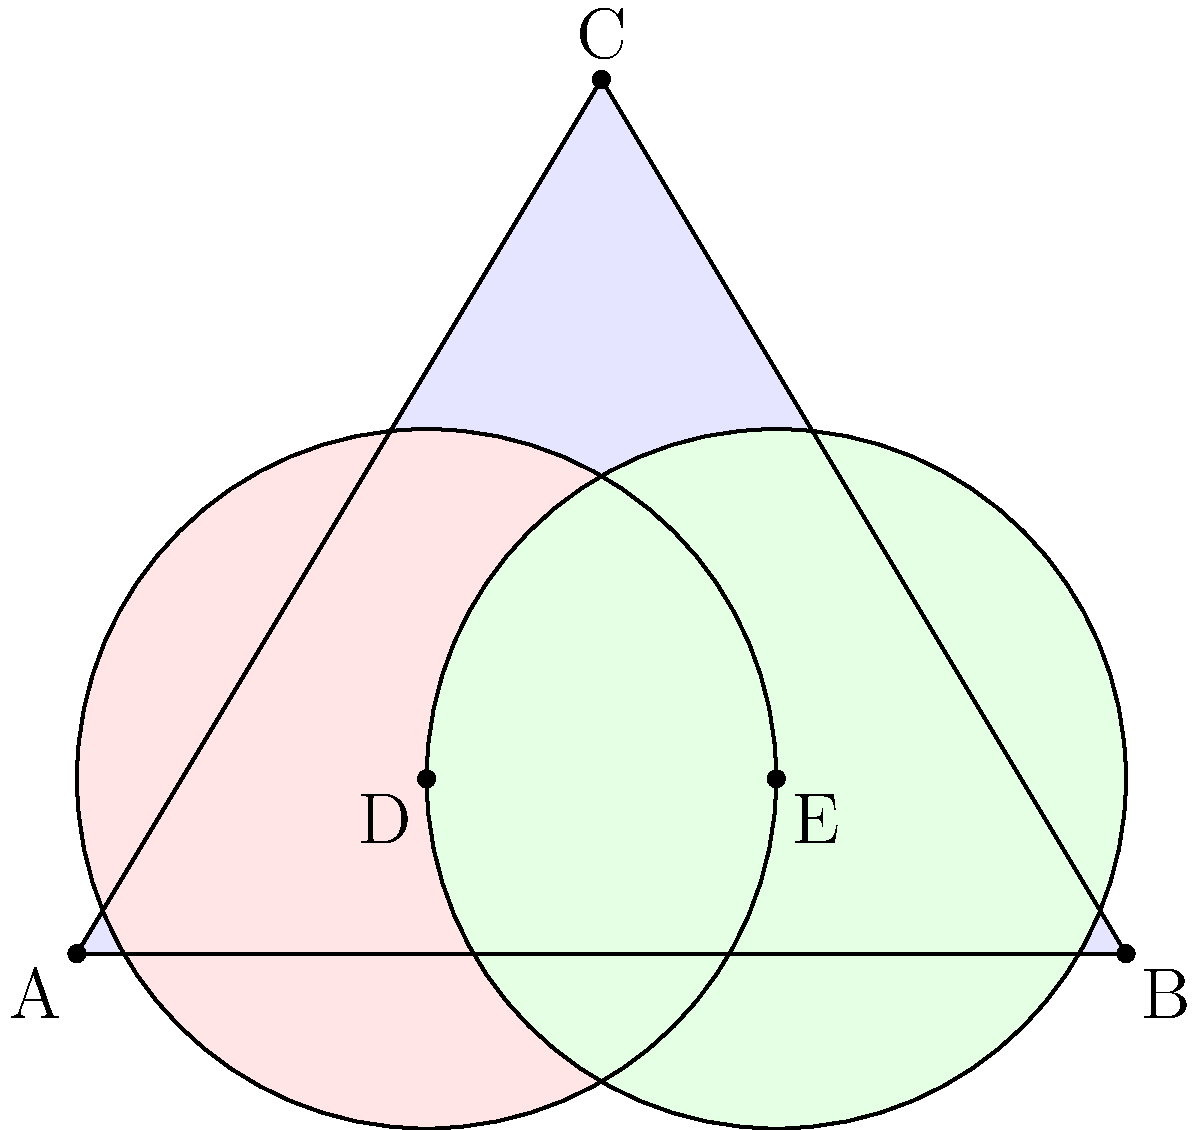In a city's crime mapping system, a triangular area ABC represents a neighborhood with coordinates A(0,0), B(6,0), and C(3,5). Two circular police precincts with radius 2 units are centered at D(2,1) and E(4,1). Calculate the area of the region that is covered by both precincts but lies outside the triangular neighborhood. How might this information be useful for optimizing police resource allocation? To solve this problem, we'll follow these steps:

1) First, we need to find the area of intersection between the two circular precincts.
   The distance between the centers D and E is:
   $DE = \sqrt{(4-2)^2 + (1-1)^2} = 2$

   For two circles of radius $r$ with centers $d$ apart, the area of intersection is:
   $A = 2r^2 \arccos(\frac{d}{2r}) - d\sqrt{r^2 - \frac{d^2}{4}}$

   Here, $r = 2$ and $d = 2$, so:
   $A = 2(2^2) \arccos(\frac{2}{2(2)}) - 2\sqrt{2^2 - \frac{2^2}{4}}$
   $= 8 \arccos(0.5) - 2\sqrt{3} \approx 6.28$ square units

2) Next, we need to find the area of this intersection that lies outside the triangle.
   The intersection forms a lens shape. We can approximate that about 3/4 of this lens 
   lies outside the triangle.

   So, the area we're looking for is approximately:
   $\frac{3}{4} * 6.28 \approx 4.71$ square units

3) This information can be useful for optimizing police resource allocation in several ways:
   - It identifies areas of overlapping coverage, which might indicate over-allocation of resources.
   - It highlights gaps in coverage (areas outside both precincts and the neighborhood).
   - It can help in redrawing precinct boundaries to ensure more efficient coverage.
   - It can guide decisions on where to place new police stations or mobile units.
   - It can be used to analyze response times and patrol routes.
Answer: Approximately 4.71 square units 